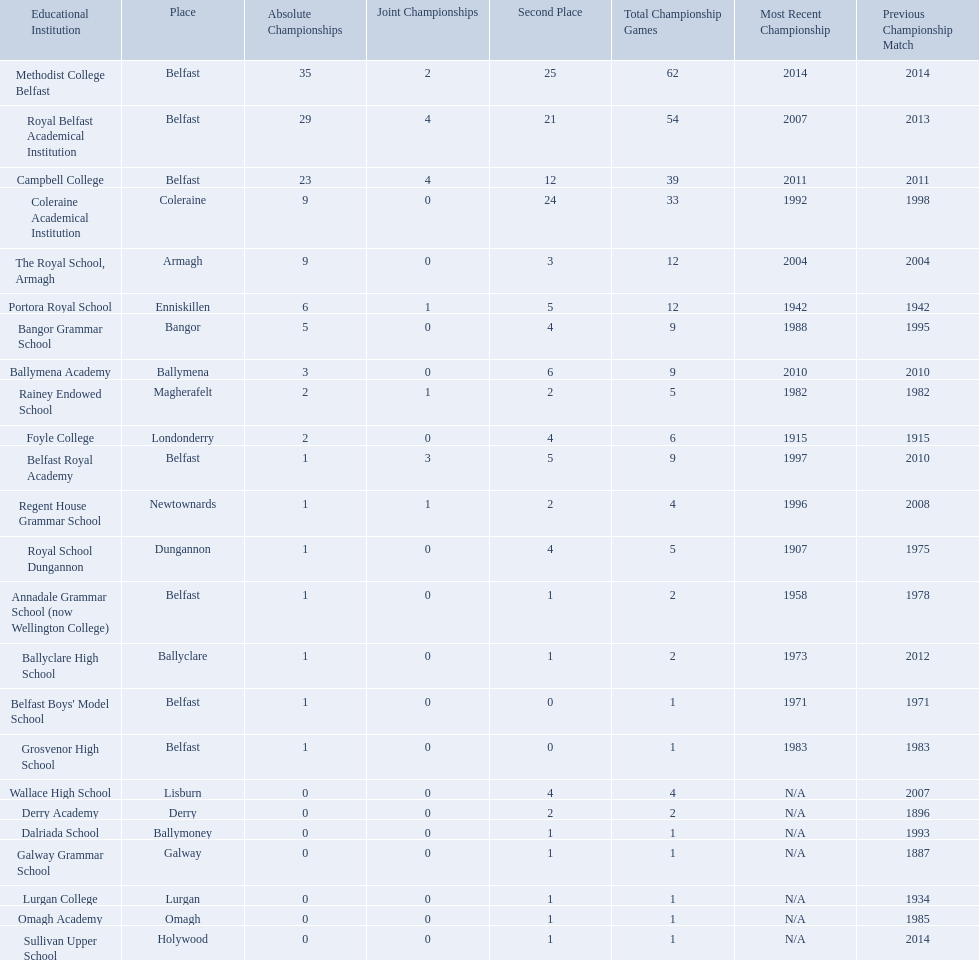How many outright titles does coleraine academical institution have? 9. What other school has this amount of outright titles The Royal School, Armagh. Which schools are listed? Methodist College Belfast, Royal Belfast Academical Institution, Campbell College, Coleraine Academical Institution, The Royal School, Armagh, Portora Royal School, Bangor Grammar School, Ballymena Academy, Rainey Endowed School, Foyle College, Belfast Royal Academy, Regent House Grammar School, Royal School Dungannon, Annadale Grammar School (now Wellington College), Ballyclare High School, Belfast Boys' Model School, Grosvenor High School, Wallace High School, Derry Academy, Dalriada School, Galway Grammar School, Lurgan College, Omagh Academy, Sullivan Upper School. When did campbell college win the title last? 2011. When did regent house grammar school win the title last? 1996. Of those two who had the most recent title win? Campbell College. What is the most recent win of campbell college? 2011. What is the most recent win of regent house grammar school? 1996. Which date is more recent? 2011. What is the name of the school with this date? Campbell College. 